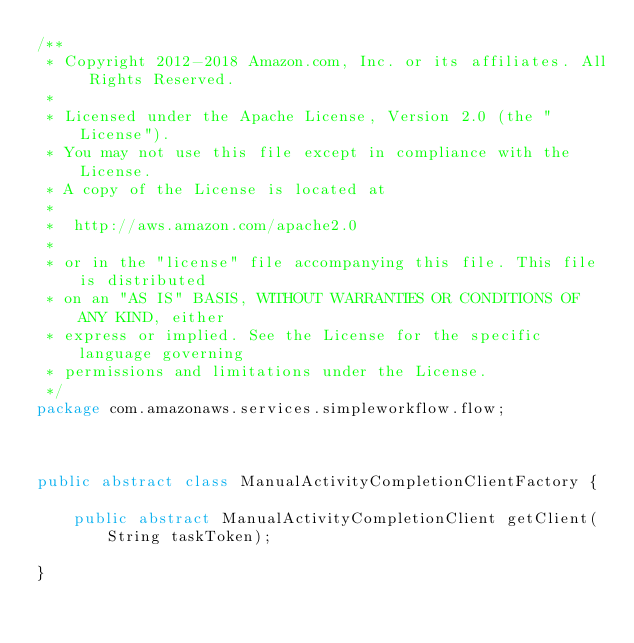<code> <loc_0><loc_0><loc_500><loc_500><_Java_>/**
 * Copyright 2012-2018 Amazon.com, Inc. or its affiliates. All Rights Reserved.
 *
 * Licensed under the Apache License, Version 2.0 (the "License").
 * You may not use this file except in compliance with the License.
 * A copy of the License is located at
 *
 *  http://aws.amazon.com/apache2.0
 *
 * or in the "license" file accompanying this file. This file is distributed
 * on an "AS IS" BASIS, WITHOUT WARRANTIES OR CONDITIONS OF ANY KIND, either
 * express or implied. See the License for the specific language governing
 * permissions and limitations under the License.
 */
package com.amazonaws.services.simpleworkflow.flow;



public abstract class ManualActivityCompletionClientFactory {

    public abstract ManualActivityCompletionClient getClient(String taskToken);
    
}
</code> 